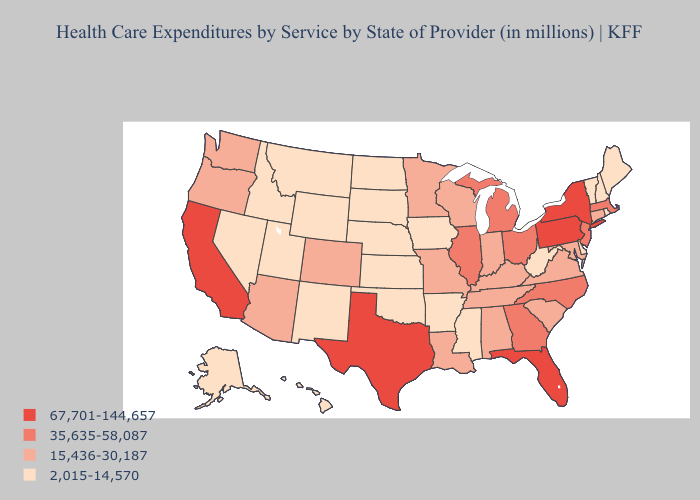What is the lowest value in the USA?
Short answer required. 2,015-14,570. Name the states that have a value in the range 67,701-144,657?
Short answer required. California, Florida, New York, Pennsylvania, Texas. Among the states that border Colorado , does Arizona have the lowest value?
Keep it brief. No. How many symbols are there in the legend?
Quick response, please. 4. What is the value of North Carolina?
Quick response, please. 35,635-58,087. What is the value of Louisiana?
Quick response, please. 15,436-30,187. Which states have the lowest value in the USA?
Concise answer only. Alaska, Arkansas, Delaware, Hawaii, Idaho, Iowa, Kansas, Maine, Mississippi, Montana, Nebraska, Nevada, New Hampshire, New Mexico, North Dakota, Oklahoma, Rhode Island, South Dakota, Utah, Vermont, West Virginia, Wyoming. Name the states that have a value in the range 15,436-30,187?
Short answer required. Alabama, Arizona, Colorado, Connecticut, Indiana, Kentucky, Louisiana, Maryland, Minnesota, Missouri, Oregon, South Carolina, Tennessee, Virginia, Washington, Wisconsin. What is the highest value in states that border Idaho?
Answer briefly. 15,436-30,187. Which states hav the highest value in the South?
Give a very brief answer. Florida, Texas. What is the value of Minnesota?
Answer briefly. 15,436-30,187. Name the states that have a value in the range 15,436-30,187?
Be succinct. Alabama, Arizona, Colorado, Connecticut, Indiana, Kentucky, Louisiana, Maryland, Minnesota, Missouri, Oregon, South Carolina, Tennessee, Virginia, Washington, Wisconsin. Which states hav the highest value in the Northeast?
Keep it brief. New York, Pennsylvania. Name the states that have a value in the range 67,701-144,657?
Write a very short answer. California, Florida, New York, Pennsylvania, Texas. Does Missouri have the same value as Maryland?
Be succinct. Yes. 